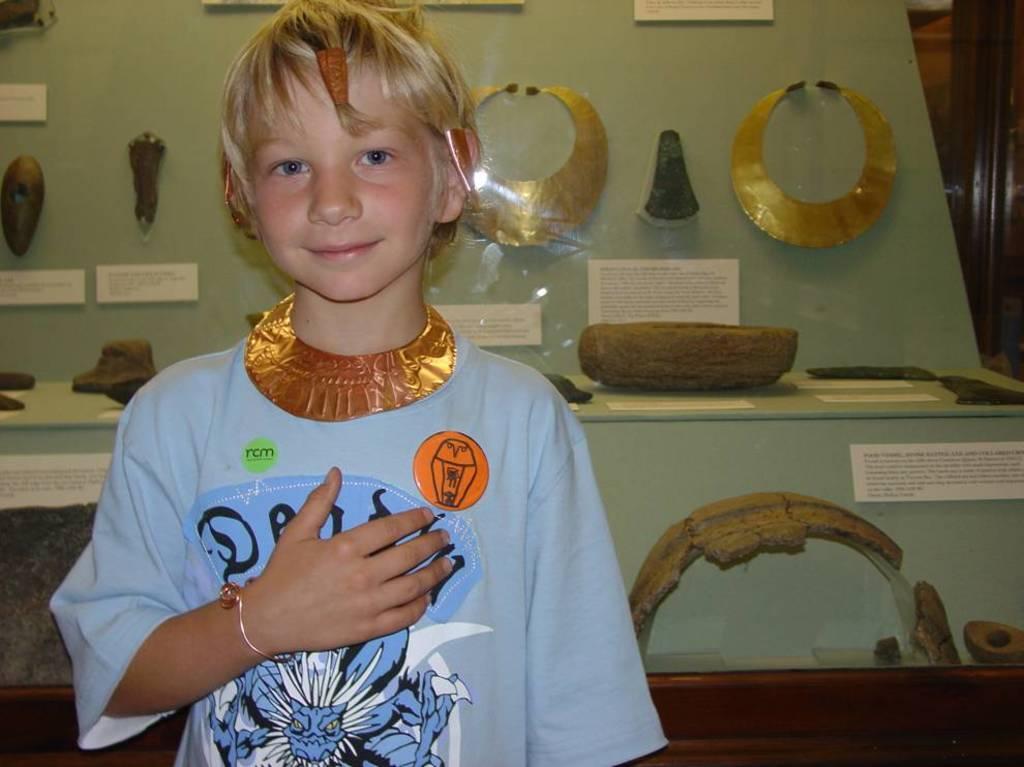In one or two sentences, can you explain what this image depicts? In the image we can see a child wearing clothes and the child is smiling. Behind the child there are Egyptian wearing ornaments. There is a piece of paper, on it there is a text. 